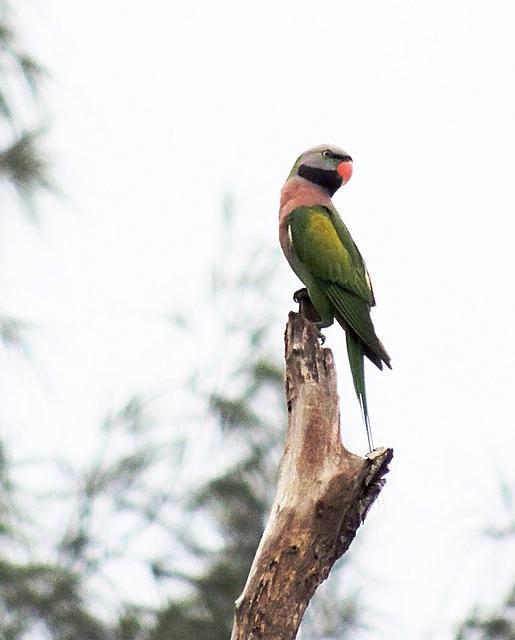How many birds can be seen?
Give a very brief answer. 1. How many people are smiling in the image?
Give a very brief answer. 0. 